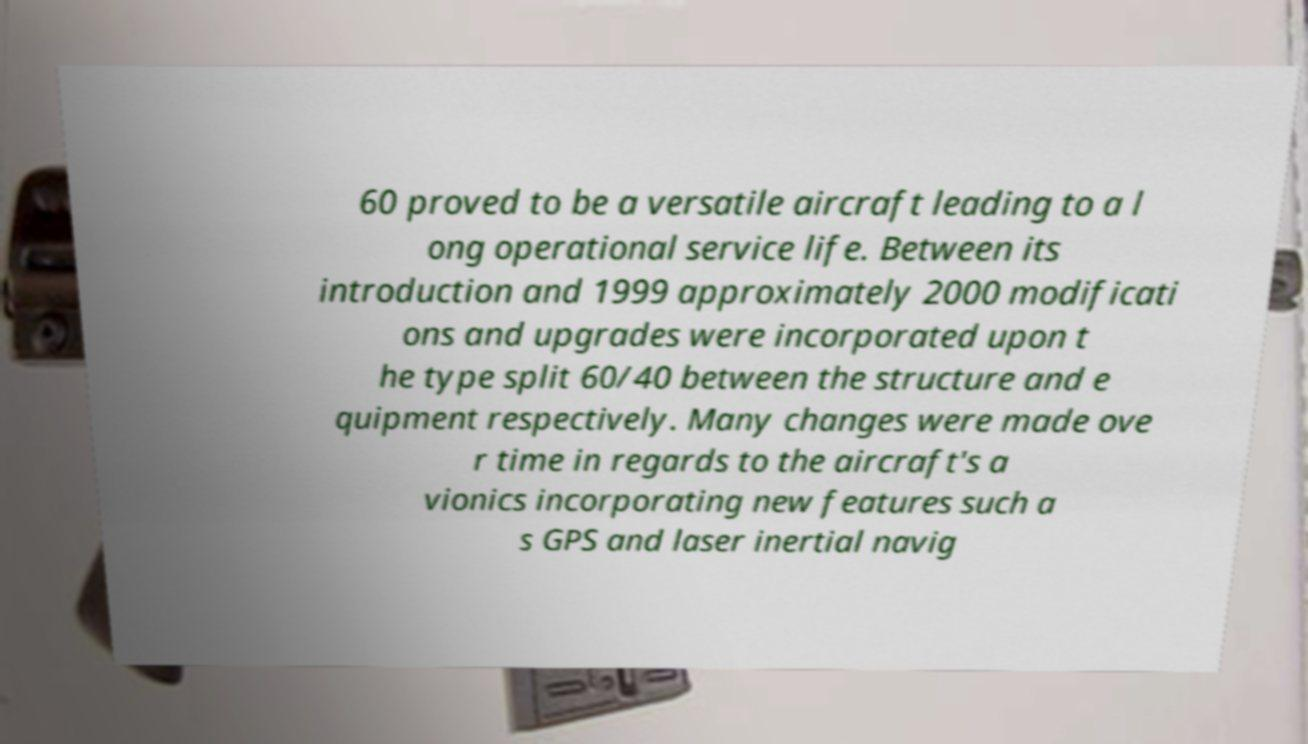Can you read and provide the text displayed in the image?This photo seems to have some interesting text. Can you extract and type it out for me? 60 proved to be a versatile aircraft leading to a l ong operational service life. Between its introduction and 1999 approximately 2000 modificati ons and upgrades were incorporated upon t he type split 60/40 between the structure and e quipment respectively. Many changes were made ove r time in regards to the aircraft's a vionics incorporating new features such a s GPS and laser inertial navig 